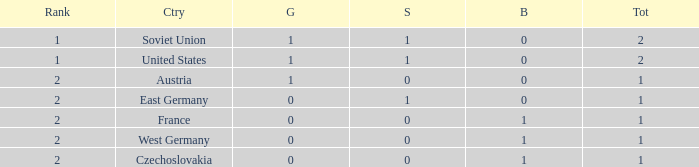What is the highest rank of Austria, which had less than 0 silvers? None. 